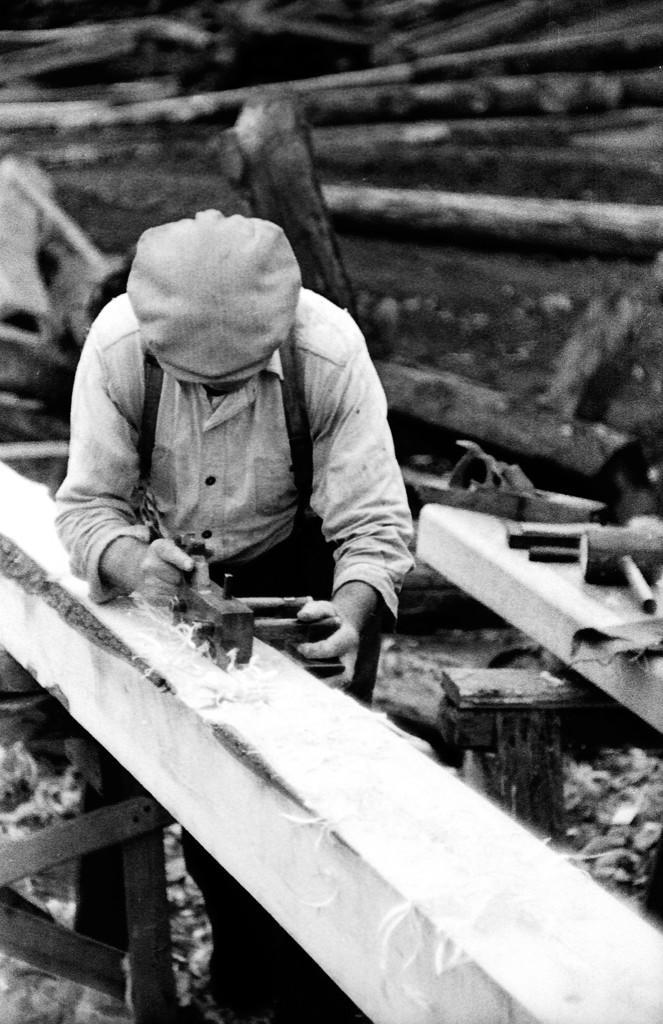How would you summarize this image in a sentence or two? In this picture I can see a person cleaning the wood, on the right side there is a hammer, in the background there are logs. 